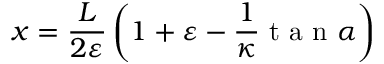Convert formula to latex. <formula><loc_0><loc_0><loc_500><loc_500>x = \frac { L } { 2 \varepsilon } \left ( { 1 + \varepsilon - \frac { 1 } { \kappa } t a n \alpha } \right )</formula> 